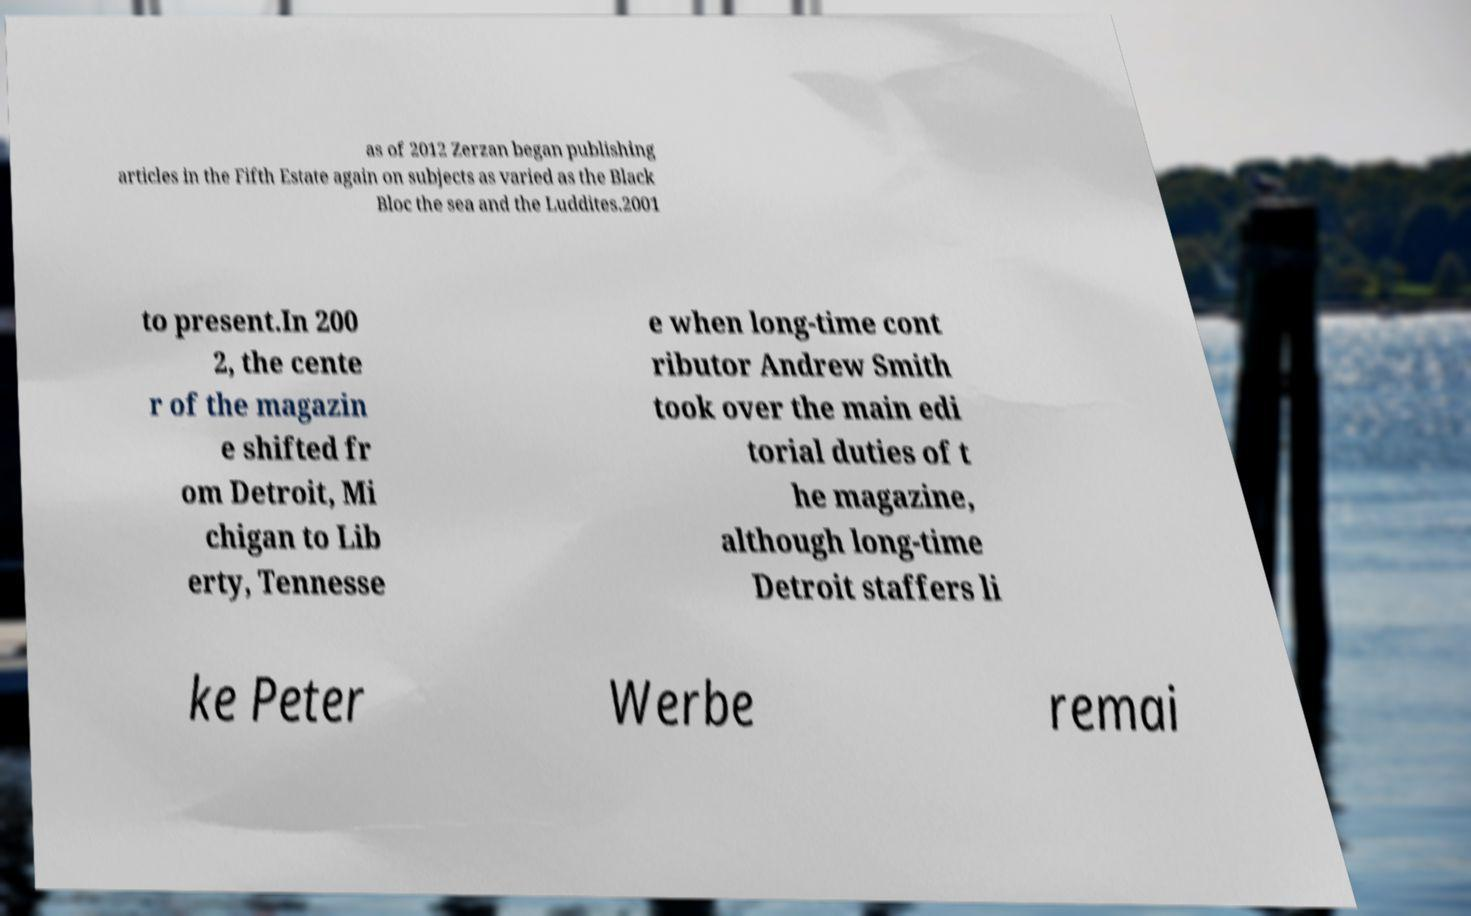Could you assist in decoding the text presented in this image and type it out clearly? as of 2012 Zerzan began publishing articles in the Fifth Estate again on subjects as varied as the Black Bloc the sea and the Luddites.2001 to present.In 200 2, the cente r of the magazin e shifted fr om Detroit, Mi chigan to Lib erty, Tennesse e when long-time cont ributor Andrew Smith took over the main edi torial duties of t he magazine, although long-time Detroit staffers li ke Peter Werbe remai 